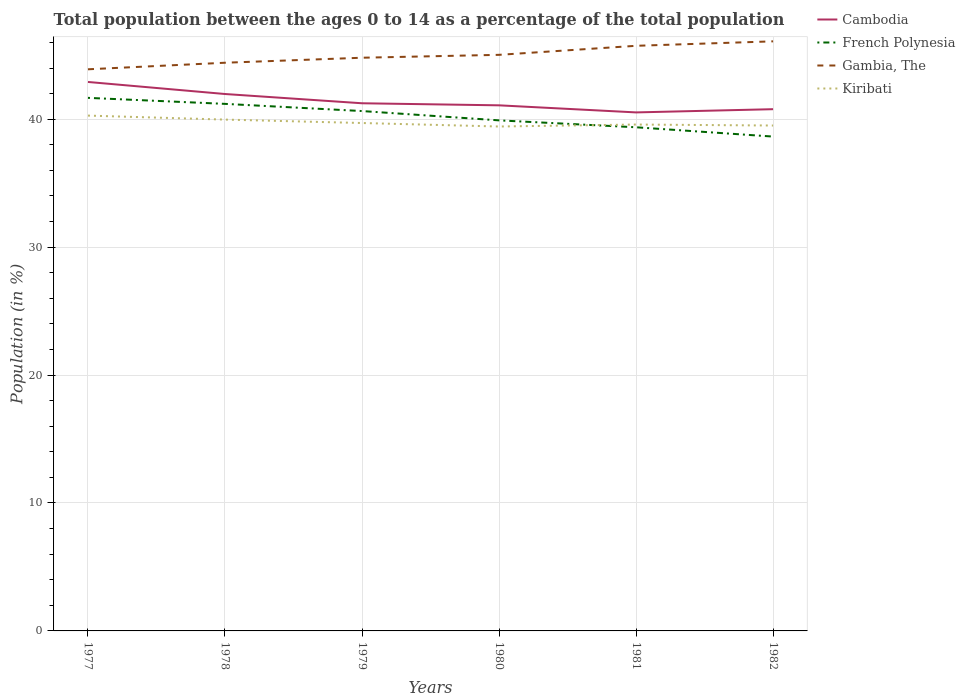Across all years, what is the maximum percentage of the population ages 0 to 14 in Gambia, The?
Your answer should be very brief. 43.9. What is the total percentage of the population ages 0 to 14 in French Polynesia in the graph?
Provide a short and direct response. 3.03. What is the difference between the highest and the second highest percentage of the population ages 0 to 14 in Gambia, The?
Provide a short and direct response. 2.18. What is the difference between the highest and the lowest percentage of the population ages 0 to 14 in Cambodia?
Ensure brevity in your answer.  2. How many lines are there?
Make the answer very short. 4. How many years are there in the graph?
Keep it short and to the point. 6. What is the difference between two consecutive major ticks on the Y-axis?
Provide a short and direct response. 10. Where does the legend appear in the graph?
Give a very brief answer. Top right. How are the legend labels stacked?
Give a very brief answer. Vertical. What is the title of the graph?
Ensure brevity in your answer.  Total population between the ages 0 to 14 as a percentage of the total population. Does "Cayman Islands" appear as one of the legend labels in the graph?
Give a very brief answer. No. What is the label or title of the Y-axis?
Offer a terse response. Population (in %). What is the Population (in %) in Cambodia in 1977?
Your answer should be very brief. 42.91. What is the Population (in %) in French Polynesia in 1977?
Make the answer very short. 41.67. What is the Population (in %) in Gambia, The in 1977?
Give a very brief answer. 43.9. What is the Population (in %) in Kiribati in 1977?
Provide a short and direct response. 40.28. What is the Population (in %) of Cambodia in 1978?
Keep it short and to the point. 41.97. What is the Population (in %) in French Polynesia in 1978?
Offer a very short reply. 41.2. What is the Population (in %) in Gambia, The in 1978?
Offer a terse response. 44.41. What is the Population (in %) in Kiribati in 1978?
Ensure brevity in your answer.  39.97. What is the Population (in %) of Cambodia in 1979?
Offer a very short reply. 41.24. What is the Population (in %) of French Polynesia in 1979?
Give a very brief answer. 40.64. What is the Population (in %) of Gambia, The in 1979?
Give a very brief answer. 44.8. What is the Population (in %) in Kiribati in 1979?
Provide a short and direct response. 39.7. What is the Population (in %) of Cambodia in 1980?
Provide a succinct answer. 41.08. What is the Population (in %) in French Polynesia in 1980?
Provide a succinct answer. 39.91. What is the Population (in %) in Gambia, The in 1980?
Offer a very short reply. 45.03. What is the Population (in %) in Kiribati in 1980?
Give a very brief answer. 39.43. What is the Population (in %) of Cambodia in 1981?
Keep it short and to the point. 40.53. What is the Population (in %) of French Polynesia in 1981?
Offer a terse response. 39.37. What is the Population (in %) of Gambia, The in 1981?
Your answer should be very brief. 45.74. What is the Population (in %) of Kiribati in 1981?
Provide a succinct answer. 39.58. What is the Population (in %) of Cambodia in 1982?
Offer a terse response. 40.78. What is the Population (in %) of French Polynesia in 1982?
Make the answer very short. 38.64. What is the Population (in %) in Gambia, The in 1982?
Your answer should be compact. 46.08. What is the Population (in %) of Kiribati in 1982?
Offer a very short reply. 39.5. Across all years, what is the maximum Population (in %) of Cambodia?
Give a very brief answer. 42.91. Across all years, what is the maximum Population (in %) in French Polynesia?
Provide a succinct answer. 41.67. Across all years, what is the maximum Population (in %) of Gambia, The?
Provide a short and direct response. 46.08. Across all years, what is the maximum Population (in %) of Kiribati?
Provide a short and direct response. 40.28. Across all years, what is the minimum Population (in %) in Cambodia?
Your response must be concise. 40.53. Across all years, what is the minimum Population (in %) in French Polynesia?
Give a very brief answer. 38.64. Across all years, what is the minimum Population (in %) in Gambia, The?
Offer a terse response. 43.9. Across all years, what is the minimum Population (in %) of Kiribati?
Your answer should be compact. 39.43. What is the total Population (in %) in Cambodia in the graph?
Give a very brief answer. 248.51. What is the total Population (in %) of French Polynesia in the graph?
Give a very brief answer. 241.41. What is the total Population (in %) in Gambia, The in the graph?
Ensure brevity in your answer.  269.96. What is the total Population (in %) in Kiribati in the graph?
Provide a short and direct response. 238.46. What is the difference between the Population (in %) in Cambodia in 1977 and that in 1978?
Make the answer very short. 0.94. What is the difference between the Population (in %) in French Polynesia in 1977 and that in 1978?
Your answer should be very brief. 0.47. What is the difference between the Population (in %) of Gambia, The in 1977 and that in 1978?
Keep it short and to the point. -0.51. What is the difference between the Population (in %) of Kiribati in 1977 and that in 1978?
Your answer should be compact. 0.31. What is the difference between the Population (in %) in Cambodia in 1977 and that in 1979?
Ensure brevity in your answer.  1.67. What is the difference between the Population (in %) of French Polynesia in 1977 and that in 1979?
Give a very brief answer. 1.03. What is the difference between the Population (in %) in Gambia, The in 1977 and that in 1979?
Provide a short and direct response. -0.9. What is the difference between the Population (in %) of Kiribati in 1977 and that in 1979?
Your answer should be very brief. 0.58. What is the difference between the Population (in %) in Cambodia in 1977 and that in 1980?
Provide a succinct answer. 1.83. What is the difference between the Population (in %) of French Polynesia in 1977 and that in 1980?
Offer a terse response. 1.76. What is the difference between the Population (in %) in Gambia, The in 1977 and that in 1980?
Offer a very short reply. -1.13. What is the difference between the Population (in %) of Kiribati in 1977 and that in 1980?
Your answer should be compact. 0.85. What is the difference between the Population (in %) of Cambodia in 1977 and that in 1981?
Make the answer very short. 2.38. What is the difference between the Population (in %) in French Polynesia in 1977 and that in 1981?
Provide a short and direct response. 2.3. What is the difference between the Population (in %) in Gambia, The in 1977 and that in 1981?
Your answer should be very brief. -1.84. What is the difference between the Population (in %) of Kiribati in 1977 and that in 1981?
Offer a terse response. 0.7. What is the difference between the Population (in %) of Cambodia in 1977 and that in 1982?
Offer a very short reply. 2.13. What is the difference between the Population (in %) of French Polynesia in 1977 and that in 1982?
Offer a terse response. 3.03. What is the difference between the Population (in %) in Gambia, The in 1977 and that in 1982?
Your answer should be compact. -2.19. What is the difference between the Population (in %) of Kiribati in 1977 and that in 1982?
Offer a terse response. 0.78. What is the difference between the Population (in %) of Cambodia in 1978 and that in 1979?
Your answer should be compact. 0.72. What is the difference between the Population (in %) in French Polynesia in 1978 and that in 1979?
Give a very brief answer. 0.56. What is the difference between the Population (in %) in Gambia, The in 1978 and that in 1979?
Provide a short and direct response. -0.39. What is the difference between the Population (in %) of Kiribati in 1978 and that in 1979?
Your answer should be compact. 0.27. What is the difference between the Population (in %) in Cambodia in 1978 and that in 1980?
Give a very brief answer. 0.88. What is the difference between the Population (in %) in French Polynesia in 1978 and that in 1980?
Offer a terse response. 1.29. What is the difference between the Population (in %) in Gambia, The in 1978 and that in 1980?
Your answer should be very brief. -0.62. What is the difference between the Population (in %) of Kiribati in 1978 and that in 1980?
Ensure brevity in your answer.  0.54. What is the difference between the Population (in %) of Cambodia in 1978 and that in 1981?
Give a very brief answer. 1.44. What is the difference between the Population (in %) of French Polynesia in 1978 and that in 1981?
Your answer should be very brief. 1.83. What is the difference between the Population (in %) of Gambia, The in 1978 and that in 1981?
Give a very brief answer. -1.32. What is the difference between the Population (in %) in Kiribati in 1978 and that in 1981?
Make the answer very short. 0.39. What is the difference between the Population (in %) in Cambodia in 1978 and that in 1982?
Offer a terse response. 1.19. What is the difference between the Population (in %) in French Polynesia in 1978 and that in 1982?
Your answer should be very brief. 2.56. What is the difference between the Population (in %) in Gambia, The in 1978 and that in 1982?
Your answer should be very brief. -1.67. What is the difference between the Population (in %) of Kiribati in 1978 and that in 1982?
Provide a succinct answer. 0.46. What is the difference between the Population (in %) of Cambodia in 1979 and that in 1980?
Offer a very short reply. 0.16. What is the difference between the Population (in %) of French Polynesia in 1979 and that in 1980?
Your answer should be very brief. 0.73. What is the difference between the Population (in %) in Gambia, The in 1979 and that in 1980?
Keep it short and to the point. -0.23. What is the difference between the Population (in %) of Kiribati in 1979 and that in 1980?
Keep it short and to the point. 0.27. What is the difference between the Population (in %) of Cambodia in 1979 and that in 1981?
Make the answer very short. 0.71. What is the difference between the Population (in %) in French Polynesia in 1979 and that in 1981?
Give a very brief answer. 1.27. What is the difference between the Population (in %) in Gambia, The in 1979 and that in 1981?
Keep it short and to the point. -0.93. What is the difference between the Population (in %) in Kiribati in 1979 and that in 1981?
Keep it short and to the point. 0.12. What is the difference between the Population (in %) in Cambodia in 1979 and that in 1982?
Give a very brief answer. 0.46. What is the difference between the Population (in %) of French Polynesia in 1979 and that in 1982?
Give a very brief answer. 2. What is the difference between the Population (in %) of Gambia, The in 1979 and that in 1982?
Offer a very short reply. -1.28. What is the difference between the Population (in %) of Kiribati in 1979 and that in 1982?
Your answer should be compact. 0.2. What is the difference between the Population (in %) of Cambodia in 1980 and that in 1981?
Offer a very short reply. 0.55. What is the difference between the Population (in %) of French Polynesia in 1980 and that in 1981?
Offer a very short reply. 0.54. What is the difference between the Population (in %) in Gambia, The in 1980 and that in 1981?
Your answer should be compact. -0.71. What is the difference between the Population (in %) in Kiribati in 1980 and that in 1981?
Ensure brevity in your answer.  -0.15. What is the difference between the Population (in %) of Cambodia in 1980 and that in 1982?
Keep it short and to the point. 0.3. What is the difference between the Population (in %) of French Polynesia in 1980 and that in 1982?
Your response must be concise. 1.27. What is the difference between the Population (in %) of Gambia, The in 1980 and that in 1982?
Provide a short and direct response. -1.05. What is the difference between the Population (in %) in Kiribati in 1980 and that in 1982?
Offer a terse response. -0.08. What is the difference between the Population (in %) in Cambodia in 1981 and that in 1982?
Ensure brevity in your answer.  -0.25. What is the difference between the Population (in %) of French Polynesia in 1981 and that in 1982?
Offer a terse response. 0.73. What is the difference between the Population (in %) of Gambia, The in 1981 and that in 1982?
Make the answer very short. -0.35. What is the difference between the Population (in %) of Kiribati in 1981 and that in 1982?
Provide a short and direct response. 0.08. What is the difference between the Population (in %) of Cambodia in 1977 and the Population (in %) of French Polynesia in 1978?
Offer a very short reply. 1.71. What is the difference between the Population (in %) in Cambodia in 1977 and the Population (in %) in Gambia, The in 1978?
Provide a succinct answer. -1.5. What is the difference between the Population (in %) in Cambodia in 1977 and the Population (in %) in Kiribati in 1978?
Keep it short and to the point. 2.94. What is the difference between the Population (in %) of French Polynesia in 1977 and the Population (in %) of Gambia, The in 1978?
Ensure brevity in your answer.  -2.75. What is the difference between the Population (in %) in French Polynesia in 1977 and the Population (in %) in Kiribati in 1978?
Your answer should be compact. 1.7. What is the difference between the Population (in %) of Gambia, The in 1977 and the Population (in %) of Kiribati in 1978?
Give a very brief answer. 3.93. What is the difference between the Population (in %) in Cambodia in 1977 and the Population (in %) in French Polynesia in 1979?
Ensure brevity in your answer.  2.27. What is the difference between the Population (in %) in Cambodia in 1977 and the Population (in %) in Gambia, The in 1979?
Your answer should be very brief. -1.89. What is the difference between the Population (in %) in Cambodia in 1977 and the Population (in %) in Kiribati in 1979?
Provide a succinct answer. 3.21. What is the difference between the Population (in %) in French Polynesia in 1977 and the Population (in %) in Gambia, The in 1979?
Offer a terse response. -3.14. What is the difference between the Population (in %) in French Polynesia in 1977 and the Population (in %) in Kiribati in 1979?
Offer a terse response. 1.97. What is the difference between the Population (in %) of Gambia, The in 1977 and the Population (in %) of Kiribati in 1979?
Offer a very short reply. 4.2. What is the difference between the Population (in %) of Cambodia in 1977 and the Population (in %) of French Polynesia in 1980?
Make the answer very short. 3. What is the difference between the Population (in %) in Cambodia in 1977 and the Population (in %) in Gambia, The in 1980?
Provide a short and direct response. -2.12. What is the difference between the Population (in %) in Cambodia in 1977 and the Population (in %) in Kiribati in 1980?
Offer a terse response. 3.48. What is the difference between the Population (in %) of French Polynesia in 1977 and the Population (in %) of Gambia, The in 1980?
Provide a succinct answer. -3.36. What is the difference between the Population (in %) in French Polynesia in 1977 and the Population (in %) in Kiribati in 1980?
Keep it short and to the point. 2.24. What is the difference between the Population (in %) in Gambia, The in 1977 and the Population (in %) in Kiribati in 1980?
Provide a short and direct response. 4.47. What is the difference between the Population (in %) of Cambodia in 1977 and the Population (in %) of French Polynesia in 1981?
Your response must be concise. 3.54. What is the difference between the Population (in %) of Cambodia in 1977 and the Population (in %) of Gambia, The in 1981?
Offer a terse response. -2.83. What is the difference between the Population (in %) of Cambodia in 1977 and the Population (in %) of Kiribati in 1981?
Provide a short and direct response. 3.33. What is the difference between the Population (in %) in French Polynesia in 1977 and the Population (in %) in Gambia, The in 1981?
Ensure brevity in your answer.  -4.07. What is the difference between the Population (in %) of French Polynesia in 1977 and the Population (in %) of Kiribati in 1981?
Ensure brevity in your answer.  2.09. What is the difference between the Population (in %) of Gambia, The in 1977 and the Population (in %) of Kiribati in 1981?
Ensure brevity in your answer.  4.32. What is the difference between the Population (in %) of Cambodia in 1977 and the Population (in %) of French Polynesia in 1982?
Your answer should be compact. 4.27. What is the difference between the Population (in %) in Cambodia in 1977 and the Population (in %) in Gambia, The in 1982?
Your answer should be compact. -3.18. What is the difference between the Population (in %) in Cambodia in 1977 and the Population (in %) in Kiribati in 1982?
Provide a short and direct response. 3.41. What is the difference between the Population (in %) of French Polynesia in 1977 and the Population (in %) of Gambia, The in 1982?
Your response must be concise. -4.42. What is the difference between the Population (in %) in French Polynesia in 1977 and the Population (in %) in Kiribati in 1982?
Your answer should be compact. 2.16. What is the difference between the Population (in %) in Gambia, The in 1977 and the Population (in %) in Kiribati in 1982?
Offer a terse response. 4.4. What is the difference between the Population (in %) in Cambodia in 1978 and the Population (in %) in French Polynesia in 1979?
Give a very brief answer. 1.33. What is the difference between the Population (in %) of Cambodia in 1978 and the Population (in %) of Gambia, The in 1979?
Give a very brief answer. -2.84. What is the difference between the Population (in %) in Cambodia in 1978 and the Population (in %) in Kiribati in 1979?
Your answer should be very brief. 2.27. What is the difference between the Population (in %) of French Polynesia in 1978 and the Population (in %) of Gambia, The in 1979?
Your answer should be very brief. -3.61. What is the difference between the Population (in %) of French Polynesia in 1978 and the Population (in %) of Kiribati in 1979?
Provide a short and direct response. 1.5. What is the difference between the Population (in %) of Gambia, The in 1978 and the Population (in %) of Kiribati in 1979?
Make the answer very short. 4.71. What is the difference between the Population (in %) in Cambodia in 1978 and the Population (in %) in French Polynesia in 1980?
Make the answer very short. 2.06. What is the difference between the Population (in %) in Cambodia in 1978 and the Population (in %) in Gambia, The in 1980?
Keep it short and to the point. -3.06. What is the difference between the Population (in %) of Cambodia in 1978 and the Population (in %) of Kiribati in 1980?
Provide a short and direct response. 2.54. What is the difference between the Population (in %) of French Polynesia in 1978 and the Population (in %) of Gambia, The in 1980?
Your answer should be compact. -3.83. What is the difference between the Population (in %) in French Polynesia in 1978 and the Population (in %) in Kiribati in 1980?
Provide a succinct answer. 1.77. What is the difference between the Population (in %) in Gambia, The in 1978 and the Population (in %) in Kiribati in 1980?
Give a very brief answer. 4.98. What is the difference between the Population (in %) in Cambodia in 1978 and the Population (in %) in French Polynesia in 1981?
Your answer should be very brief. 2.6. What is the difference between the Population (in %) of Cambodia in 1978 and the Population (in %) of Gambia, The in 1981?
Offer a terse response. -3.77. What is the difference between the Population (in %) in Cambodia in 1978 and the Population (in %) in Kiribati in 1981?
Offer a very short reply. 2.39. What is the difference between the Population (in %) of French Polynesia in 1978 and the Population (in %) of Gambia, The in 1981?
Give a very brief answer. -4.54. What is the difference between the Population (in %) of French Polynesia in 1978 and the Population (in %) of Kiribati in 1981?
Ensure brevity in your answer.  1.62. What is the difference between the Population (in %) in Gambia, The in 1978 and the Population (in %) in Kiribati in 1981?
Offer a terse response. 4.83. What is the difference between the Population (in %) in Cambodia in 1978 and the Population (in %) in French Polynesia in 1982?
Your answer should be compact. 3.33. What is the difference between the Population (in %) of Cambodia in 1978 and the Population (in %) of Gambia, The in 1982?
Keep it short and to the point. -4.12. What is the difference between the Population (in %) in Cambodia in 1978 and the Population (in %) in Kiribati in 1982?
Your response must be concise. 2.46. What is the difference between the Population (in %) of French Polynesia in 1978 and the Population (in %) of Gambia, The in 1982?
Ensure brevity in your answer.  -4.89. What is the difference between the Population (in %) in French Polynesia in 1978 and the Population (in %) in Kiribati in 1982?
Your answer should be compact. 1.69. What is the difference between the Population (in %) in Gambia, The in 1978 and the Population (in %) in Kiribati in 1982?
Your response must be concise. 4.91. What is the difference between the Population (in %) in Cambodia in 1979 and the Population (in %) in French Polynesia in 1980?
Make the answer very short. 1.34. What is the difference between the Population (in %) of Cambodia in 1979 and the Population (in %) of Gambia, The in 1980?
Provide a succinct answer. -3.79. What is the difference between the Population (in %) of Cambodia in 1979 and the Population (in %) of Kiribati in 1980?
Keep it short and to the point. 1.82. What is the difference between the Population (in %) of French Polynesia in 1979 and the Population (in %) of Gambia, The in 1980?
Ensure brevity in your answer.  -4.39. What is the difference between the Population (in %) in French Polynesia in 1979 and the Population (in %) in Kiribati in 1980?
Provide a short and direct response. 1.21. What is the difference between the Population (in %) of Gambia, The in 1979 and the Population (in %) of Kiribati in 1980?
Offer a terse response. 5.38. What is the difference between the Population (in %) of Cambodia in 1979 and the Population (in %) of French Polynesia in 1981?
Give a very brief answer. 1.88. What is the difference between the Population (in %) in Cambodia in 1979 and the Population (in %) in Gambia, The in 1981?
Offer a terse response. -4.49. What is the difference between the Population (in %) of Cambodia in 1979 and the Population (in %) of Kiribati in 1981?
Your response must be concise. 1.66. What is the difference between the Population (in %) in French Polynesia in 1979 and the Population (in %) in Gambia, The in 1981?
Your answer should be compact. -5.1. What is the difference between the Population (in %) in French Polynesia in 1979 and the Population (in %) in Kiribati in 1981?
Your response must be concise. 1.05. What is the difference between the Population (in %) of Gambia, The in 1979 and the Population (in %) of Kiribati in 1981?
Give a very brief answer. 5.22. What is the difference between the Population (in %) of Cambodia in 1979 and the Population (in %) of French Polynesia in 1982?
Provide a short and direct response. 2.6. What is the difference between the Population (in %) in Cambodia in 1979 and the Population (in %) in Gambia, The in 1982?
Offer a very short reply. -4.84. What is the difference between the Population (in %) of Cambodia in 1979 and the Population (in %) of Kiribati in 1982?
Provide a succinct answer. 1.74. What is the difference between the Population (in %) of French Polynesia in 1979 and the Population (in %) of Gambia, The in 1982?
Make the answer very short. -5.45. What is the difference between the Population (in %) of French Polynesia in 1979 and the Population (in %) of Kiribati in 1982?
Offer a terse response. 1.13. What is the difference between the Population (in %) in Gambia, The in 1979 and the Population (in %) in Kiribati in 1982?
Ensure brevity in your answer.  5.3. What is the difference between the Population (in %) of Cambodia in 1980 and the Population (in %) of French Polynesia in 1981?
Your response must be concise. 1.72. What is the difference between the Population (in %) in Cambodia in 1980 and the Population (in %) in Gambia, The in 1981?
Offer a terse response. -4.65. What is the difference between the Population (in %) of Cambodia in 1980 and the Population (in %) of Kiribati in 1981?
Offer a terse response. 1.5. What is the difference between the Population (in %) in French Polynesia in 1980 and the Population (in %) in Gambia, The in 1981?
Give a very brief answer. -5.83. What is the difference between the Population (in %) of French Polynesia in 1980 and the Population (in %) of Kiribati in 1981?
Provide a short and direct response. 0.33. What is the difference between the Population (in %) in Gambia, The in 1980 and the Population (in %) in Kiribati in 1981?
Offer a very short reply. 5.45. What is the difference between the Population (in %) of Cambodia in 1980 and the Population (in %) of French Polynesia in 1982?
Offer a terse response. 2.44. What is the difference between the Population (in %) of Cambodia in 1980 and the Population (in %) of Gambia, The in 1982?
Your answer should be compact. -5. What is the difference between the Population (in %) in Cambodia in 1980 and the Population (in %) in Kiribati in 1982?
Make the answer very short. 1.58. What is the difference between the Population (in %) in French Polynesia in 1980 and the Population (in %) in Gambia, The in 1982?
Give a very brief answer. -6.18. What is the difference between the Population (in %) in French Polynesia in 1980 and the Population (in %) in Kiribati in 1982?
Your answer should be very brief. 0.4. What is the difference between the Population (in %) of Gambia, The in 1980 and the Population (in %) of Kiribati in 1982?
Your answer should be compact. 5.53. What is the difference between the Population (in %) in Cambodia in 1981 and the Population (in %) in French Polynesia in 1982?
Provide a succinct answer. 1.89. What is the difference between the Population (in %) of Cambodia in 1981 and the Population (in %) of Gambia, The in 1982?
Make the answer very short. -5.56. What is the difference between the Population (in %) of Cambodia in 1981 and the Population (in %) of Kiribati in 1982?
Ensure brevity in your answer.  1.03. What is the difference between the Population (in %) in French Polynesia in 1981 and the Population (in %) in Gambia, The in 1982?
Keep it short and to the point. -6.72. What is the difference between the Population (in %) in French Polynesia in 1981 and the Population (in %) in Kiribati in 1982?
Your answer should be compact. -0.14. What is the difference between the Population (in %) in Gambia, The in 1981 and the Population (in %) in Kiribati in 1982?
Make the answer very short. 6.23. What is the average Population (in %) of Cambodia per year?
Provide a short and direct response. 41.42. What is the average Population (in %) of French Polynesia per year?
Keep it short and to the point. 40.24. What is the average Population (in %) in Gambia, The per year?
Ensure brevity in your answer.  44.99. What is the average Population (in %) of Kiribati per year?
Your answer should be compact. 39.74. In the year 1977, what is the difference between the Population (in %) of Cambodia and Population (in %) of French Polynesia?
Provide a succinct answer. 1.24. In the year 1977, what is the difference between the Population (in %) of Cambodia and Population (in %) of Gambia, The?
Offer a very short reply. -0.99. In the year 1977, what is the difference between the Population (in %) in Cambodia and Population (in %) in Kiribati?
Your response must be concise. 2.63. In the year 1977, what is the difference between the Population (in %) in French Polynesia and Population (in %) in Gambia, The?
Offer a terse response. -2.23. In the year 1977, what is the difference between the Population (in %) in French Polynesia and Population (in %) in Kiribati?
Your response must be concise. 1.39. In the year 1977, what is the difference between the Population (in %) in Gambia, The and Population (in %) in Kiribati?
Your answer should be compact. 3.62. In the year 1978, what is the difference between the Population (in %) in Cambodia and Population (in %) in French Polynesia?
Your response must be concise. 0.77. In the year 1978, what is the difference between the Population (in %) of Cambodia and Population (in %) of Gambia, The?
Keep it short and to the point. -2.44. In the year 1978, what is the difference between the Population (in %) of Cambodia and Population (in %) of Kiribati?
Ensure brevity in your answer.  2. In the year 1978, what is the difference between the Population (in %) in French Polynesia and Population (in %) in Gambia, The?
Your answer should be very brief. -3.21. In the year 1978, what is the difference between the Population (in %) in French Polynesia and Population (in %) in Kiribati?
Your response must be concise. 1.23. In the year 1978, what is the difference between the Population (in %) of Gambia, The and Population (in %) of Kiribati?
Your answer should be very brief. 4.44. In the year 1979, what is the difference between the Population (in %) in Cambodia and Population (in %) in French Polynesia?
Offer a very short reply. 0.61. In the year 1979, what is the difference between the Population (in %) in Cambodia and Population (in %) in Gambia, The?
Ensure brevity in your answer.  -3.56. In the year 1979, what is the difference between the Population (in %) in Cambodia and Population (in %) in Kiribati?
Keep it short and to the point. 1.54. In the year 1979, what is the difference between the Population (in %) in French Polynesia and Population (in %) in Gambia, The?
Keep it short and to the point. -4.17. In the year 1979, what is the difference between the Population (in %) in French Polynesia and Population (in %) in Kiribati?
Ensure brevity in your answer.  0.94. In the year 1979, what is the difference between the Population (in %) in Gambia, The and Population (in %) in Kiribati?
Offer a very short reply. 5.1. In the year 1980, what is the difference between the Population (in %) in Cambodia and Population (in %) in French Polynesia?
Offer a terse response. 1.18. In the year 1980, what is the difference between the Population (in %) of Cambodia and Population (in %) of Gambia, The?
Your answer should be compact. -3.95. In the year 1980, what is the difference between the Population (in %) in Cambodia and Population (in %) in Kiribati?
Provide a short and direct response. 1.66. In the year 1980, what is the difference between the Population (in %) of French Polynesia and Population (in %) of Gambia, The?
Offer a very short reply. -5.12. In the year 1980, what is the difference between the Population (in %) in French Polynesia and Population (in %) in Kiribati?
Provide a short and direct response. 0.48. In the year 1980, what is the difference between the Population (in %) in Gambia, The and Population (in %) in Kiribati?
Provide a short and direct response. 5.6. In the year 1981, what is the difference between the Population (in %) of Cambodia and Population (in %) of French Polynesia?
Your answer should be very brief. 1.16. In the year 1981, what is the difference between the Population (in %) in Cambodia and Population (in %) in Gambia, The?
Keep it short and to the point. -5.21. In the year 1981, what is the difference between the Population (in %) of Cambodia and Population (in %) of Kiribati?
Provide a succinct answer. 0.95. In the year 1981, what is the difference between the Population (in %) of French Polynesia and Population (in %) of Gambia, The?
Give a very brief answer. -6.37. In the year 1981, what is the difference between the Population (in %) in French Polynesia and Population (in %) in Kiribati?
Offer a very short reply. -0.21. In the year 1981, what is the difference between the Population (in %) of Gambia, The and Population (in %) of Kiribati?
Your answer should be compact. 6.15. In the year 1982, what is the difference between the Population (in %) of Cambodia and Population (in %) of French Polynesia?
Your answer should be very brief. 2.14. In the year 1982, what is the difference between the Population (in %) in Cambodia and Population (in %) in Gambia, The?
Provide a short and direct response. -5.3. In the year 1982, what is the difference between the Population (in %) of Cambodia and Population (in %) of Kiribati?
Your response must be concise. 1.28. In the year 1982, what is the difference between the Population (in %) of French Polynesia and Population (in %) of Gambia, The?
Give a very brief answer. -7.44. In the year 1982, what is the difference between the Population (in %) of French Polynesia and Population (in %) of Kiribati?
Ensure brevity in your answer.  -0.86. In the year 1982, what is the difference between the Population (in %) of Gambia, The and Population (in %) of Kiribati?
Your answer should be compact. 6.58. What is the ratio of the Population (in %) of Cambodia in 1977 to that in 1978?
Ensure brevity in your answer.  1.02. What is the ratio of the Population (in %) in French Polynesia in 1977 to that in 1978?
Provide a succinct answer. 1.01. What is the ratio of the Population (in %) of Gambia, The in 1977 to that in 1978?
Your answer should be very brief. 0.99. What is the ratio of the Population (in %) in Cambodia in 1977 to that in 1979?
Your answer should be compact. 1.04. What is the ratio of the Population (in %) of French Polynesia in 1977 to that in 1979?
Ensure brevity in your answer.  1.03. What is the ratio of the Population (in %) of Gambia, The in 1977 to that in 1979?
Provide a short and direct response. 0.98. What is the ratio of the Population (in %) in Kiribati in 1977 to that in 1979?
Provide a succinct answer. 1.01. What is the ratio of the Population (in %) of Cambodia in 1977 to that in 1980?
Provide a short and direct response. 1.04. What is the ratio of the Population (in %) of French Polynesia in 1977 to that in 1980?
Offer a very short reply. 1.04. What is the ratio of the Population (in %) of Gambia, The in 1977 to that in 1980?
Make the answer very short. 0.97. What is the ratio of the Population (in %) in Kiribati in 1977 to that in 1980?
Your answer should be compact. 1.02. What is the ratio of the Population (in %) in Cambodia in 1977 to that in 1981?
Provide a succinct answer. 1.06. What is the ratio of the Population (in %) in French Polynesia in 1977 to that in 1981?
Offer a terse response. 1.06. What is the ratio of the Population (in %) of Gambia, The in 1977 to that in 1981?
Your answer should be very brief. 0.96. What is the ratio of the Population (in %) in Kiribati in 1977 to that in 1981?
Give a very brief answer. 1.02. What is the ratio of the Population (in %) in Cambodia in 1977 to that in 1982?
Offer a terse response. 1.05. What is the ratio of the Population (in %) of French Polynesia in 1977 to that in 1982?
Offer a very short reply. 1.08. What is the ratio of the Population (in %) of Gambia, The in 1977 to that in 1982?
Offer a very short reply. 0.95. What is the ratio of the Population (in %) of Kiribati in 1977 to that in 1982?
Your response must be concise. 1.02. What is the ratio of the Population (in %) in Cambodia in 1978 to that in 1979?
Make the answer very short. 1.02. What is the ratio of the Population (in %) of French Polynesia in 1978 to that in 1979?
Offer a terse response. 1.01. What is the ratio of the Population (in %) in Cambodia in 1978 to that in 1980?
Your answer should be very brief. 1.02. What is the ratio of the Population (in %) in French Polynesia in 1978 to that in 1980?
Ensure brevity in your answer.  1.03. What is the ratio of the Population (in %) of Gambia, The in 1978 to that in 1980?
Your response must be concise. 0.99. What is the ratio of the Population (in %) of Kiribati in 1978 to that in 1980?
Ensure brevity in your answer.  1.01. What is the ratio of the Population (in %) in Cambodia in 1978 to that in 1981?
Provide a short and direct response. 1.04. What is the ratio of the Population (in %) of French Polynesia in 1978 to that in 1981?
Your answer should be compact. 1.05. What is the ratio of the Population (in %) of Gambia, The in 1978 to that in 1981?
Offer a terse response. 0.97. What is the ratio of the Population (in %) of Kiribati in 1978 to that in 1981?
Ensure brevity in your answer.  1.01. What is the ratio of the Population (in %) of Cambodia in 1978 to that in 1982?
Keep it short and to the point. 1.03. What is the ratio of the Population (in %) in French Polynesia in 1978 to that in 1982?
Give a very brief answer. 1.07. What is the ratio of the Population (in %) of Gambia, The in 1978 to that in 1982?
Provide a succinct answer. 0.96. What is the ratio of the Population (in %) of Kiribati in 1978 to that in 1982?
Ensure brevity in your answer.  1.01. What is the ratio of the Population (in %) in Cambodia in 1979 to that in 1980?
Provide a succinct answer. 1. What is the ratio of the Population (in %) of French Polynesia in 1979 to that in 1980?
Ensure brevity in your answer.  1.02. What is the ratio of the Population (in %) of Gambia, The in 1979 to that in 1980?
Provide a succinct answer. 0.99. What is the ratio of the Population (in %) in Kiribati in 1979 to that in 1980?
Ensure brevity in your answer.  1.01. What is the ratio of the Population (in %) in Cambodia in 1979 to that in 1981?
Provide a short and direct response. 1.02. What is the ratio of the Population (in %) of French Polynesia in 1979 to that in 1981?
Your response must be concise. 1.03. What is the ratio of the Population (in %) in Gambia, The in 1979 to that in 1981?
Make the answer very short. 0.98. What is the ratio of the Population (in %) in Kiribati in 1979 to that in 1981?
Ensure brevity in your answer.  1. What is the ratio of the Population (in %) of Cambodia in 1979 to that in 1982?
Your answer should be compact. 1.01. What is the ratio of the Population (in %) of French Polynesia in 1979 to that in 1982?
Offer a terse response. 1.05. What is the ratio of the Population (in %) in Gambia, The in 1979 to that in 1982?
Ensure brevity in your answer.  0.97. What is the ratio of the Population (in %) in Cambodia in 1980 to that in 1981?
Offer a very short reply. 1.01. What is the ratio of the Population (in %) in French Polynesia in 1980 to that in 1981?
Your answer should be compact. 1.01. What is the ratio of the Population (in %) in Gambia, The in 1980 to that in 1981?
Offer a terse response. 0.98. What is the ratio of the Population (in %) of Cambodia in 1980 to that in 1982?
Offer a terse response. 1.01. What is the ratio of the Population (in %) of French Polynesia in 1980 to that in 1982?
Offer a very short reply. 1.03. What is the ratio of the Population (in %) of Gambia, The in 1980 to that in 1982?
Offer a terse response. 0.98. What is the ratio of the Population (in %) in Kiribati in 1980 to that in 1982?
Provide a succinct answer. 1. What is the ratio of the Population (in %) in Cambodia in 1981 to that in 1982?
Provide a short and direct response. 0.99. What is the ratio of the Population (in %) of French Polynesia in 1981 to that in 1982?
Give a very brief answer. 1.02. What is the ratio of the Population (in %) in Kiribati in 1981 to that in 1982?
Provide a short and direct response. 1. What is the difference between the highest and the second highest Population (in %) of Cambodia?
Your response must be concise. 0.94. What is the difference between the highest and the second highest Population (in %) in French Polynesia?
Offer a very short reply. 0.47. What is the difference between the highest and the second highest Population (in %) in Gambia, The?
Your answer should be compact. 0.35. What is the difference between the highest and the second highest Population (in %) of Kiribati?
Your response must be concise. 0.31. What is the difference between the highest and the lowest Population (in %) of Cambodia?
Your answer should be compact. 2.38. What is the difference between the highest and the lowest Population (in %) of French Polynesia?
Your answer should be compact. 3.03. What is the difference between the highest and the lowest Population (in %) in Gambia, The?
Keep it short and to the point. 2.19. What is the difference between the highest and the lowest Population (in %) in Kiribati?
Make the answer very short. 0.85. 